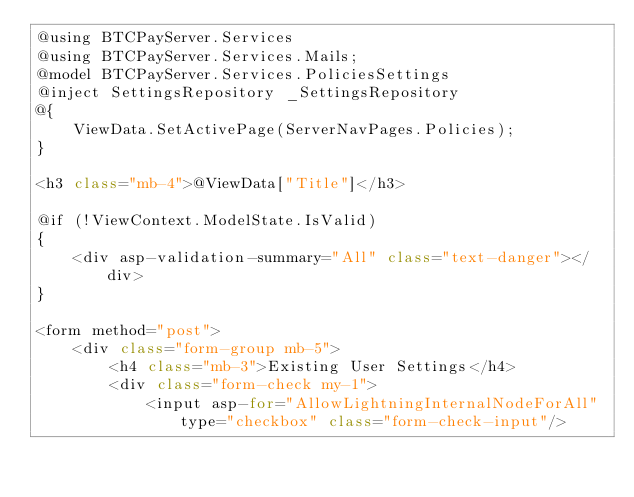Convert code to text. <code><loc_0><loc_0><loc_500><loc_500><_C#_>@using BTCPayServer.Services
@using BTCPayServer.Services.Mails;
@model BTCPayServer.Services.PoliciesSettings
@inject SettingsRepository _SettingsRepository
@{
    ViewData.SetActivePage(ServerNavPages.Policies);
}

<h3 class="mb-4">@ViewData["Title"]</h3>

@if (!ViewContext.ModelState.IsValid)
{
    <div asp-validation-summary="All" class="text-danger"></div>
}

<form method="post">
    <div class="form-group mb-5">
        <h4 class="mb-3">Existing User Settings</h4>
        <div class="form-check my-1">
            <input asp-for="AllowLightningInternalNodeForAll" type="checkbox" class="form-check-input"/></code> 